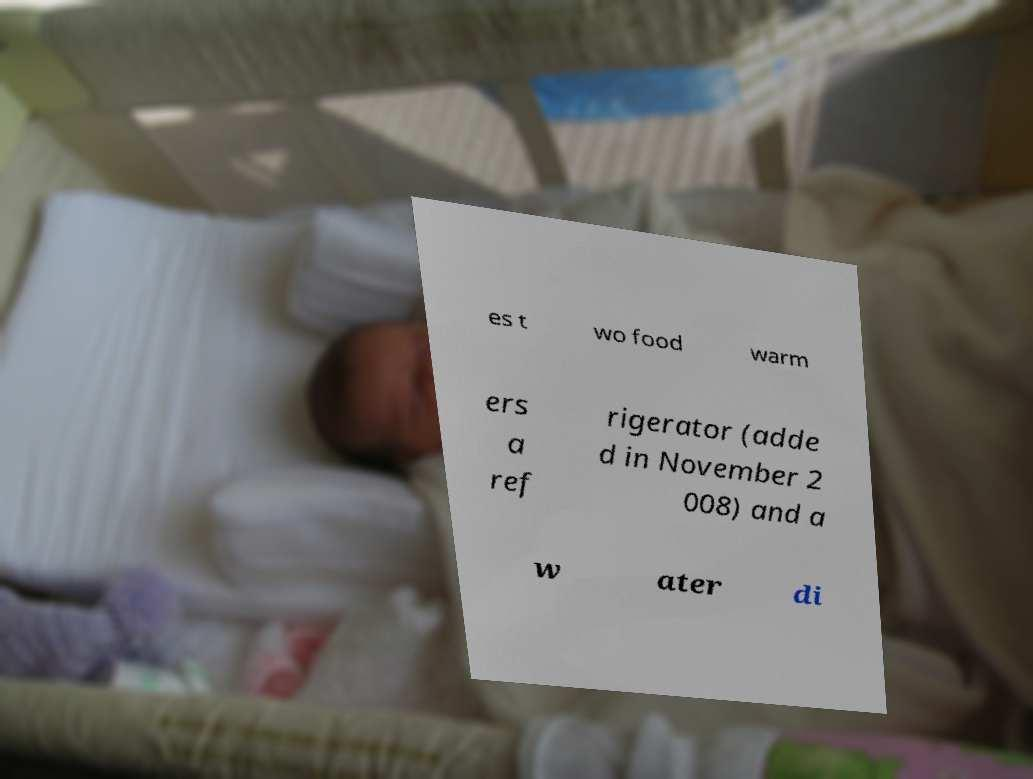Please read and relay the text visible in this image. What does it say? es t wo food warm ers a ref rigerator (adde d in November 2 008) and a w ater di 